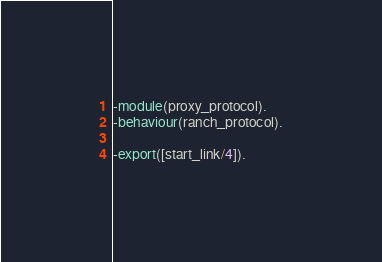<code> <loc_0><loc_0><loc_500><loc_500><_Erlang_>-module(proxy_protocol).
-behaviour(ranch_protocol).

-export([start_link/4]).</code> 